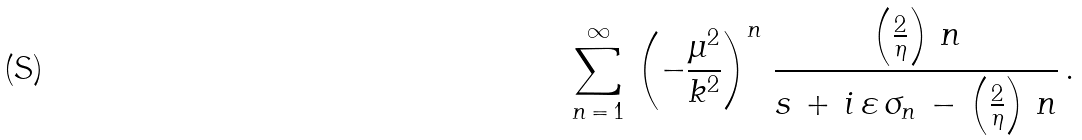<formula> <loc_0><loc_0><loc_500><loc_500>\sum _ { n \, = \, 1 } ^ { \infty } \, \left ( - \frac { \mu ^ { 2 } } { k ^ { 2 } } \right ) ^ { n } \, \frac { \left ( \frac { 2 } { \eta } \right ) \, n } { s \, + \, i \, \varepsilon \, \sigma _ { n } \, - \, \left ( \frac { 2 } { \eta } \right ) \, n } \, .</formula> 